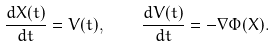<formula> <loc_0><loc_0><loc_500><loc_500>\frac { d { X } ( t ) } { d t } = { V } ( t ) , \quad \frac { d { V } ( t ) } { d t } = - \nabla \Phi ( { X } ) .</formula> 